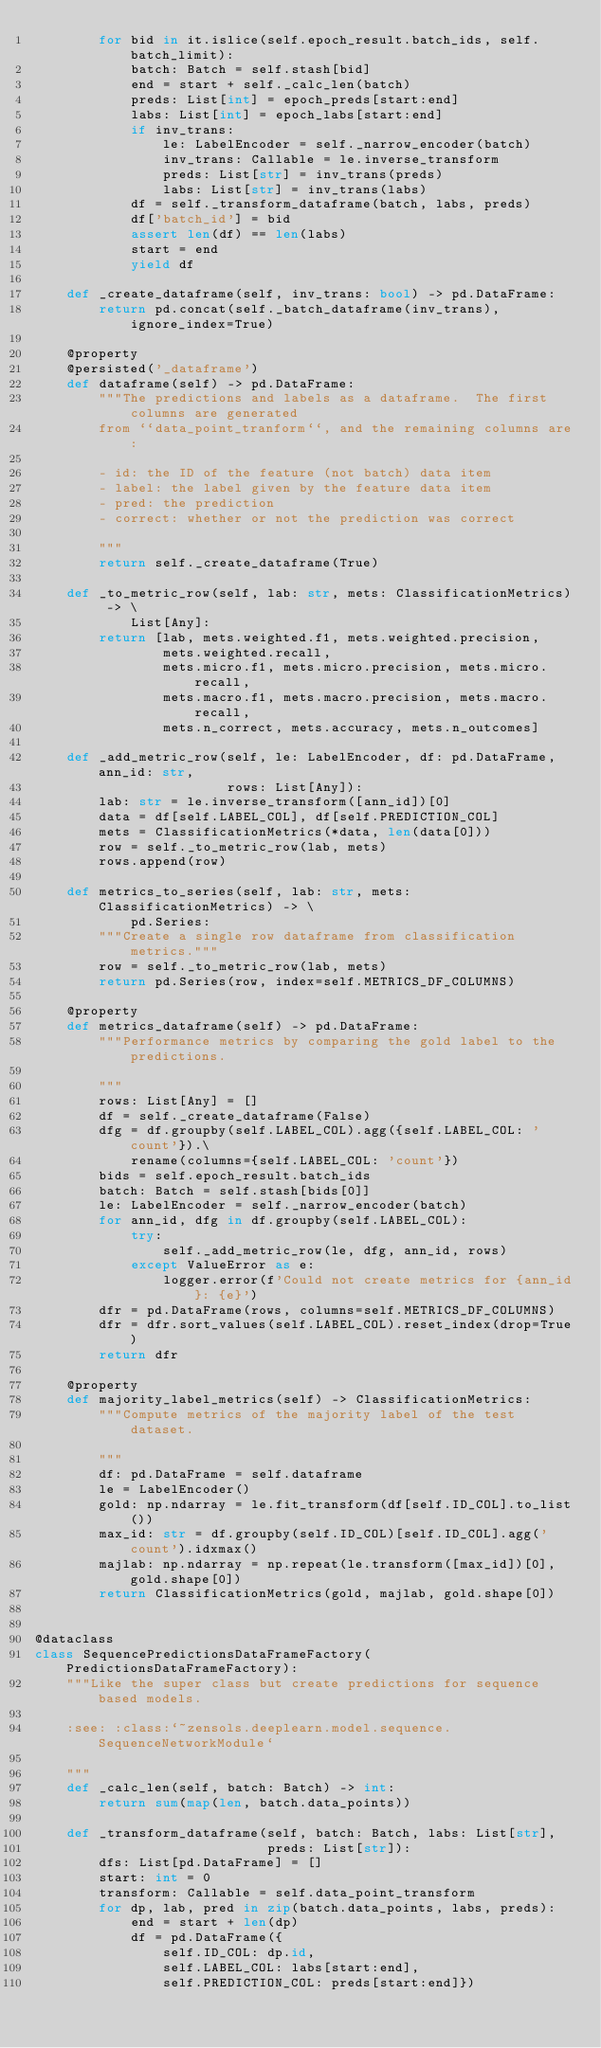<code> <loc_0><loc_0><loc_500><loc_500><_Python_>        for bid in it.islice(self.epoch_result.batch_ids, self.batch_limit):
            batch: Batch = self.stash[bid]
            end = start + self._calc_len(batch)
            preds: List[int] = epoch_preds[start:end]
            labs: List[int] = epoch_labs[start:end]
            if inv_trans:
                le: LabelEncoder = self._narrow_encoder(batch)
                inv_trans: Callable = le.inverse_transform
                preds: List[str] = inv_trans(preds)
                labs: List[str] = inv_trans(labs)
            df = self._transform_dataframe(batch, labs, preds)
            df['batch_id'] = bid
            assert len(df) == len(labs)
            start = end
            yield df

    def _create_dataframe(self, inv_trans: bool) -> pd.DataFrame:
        return pd.concat(self._batch_dataframe(inv_trans), ignore_index=True)

    @property
    @persisted('_dataframe')
    def dataframe(self) -> pd.DataFrame:
        """The predictions and labels as a dataframe.  The first columns are generated
        from ``data_point_tranform``, and the remaining columns are:

        - id: the ID of the feature (not batch) data item
        - label: the label given by the feature data item
        - pred: the prediction
        - correct: whether or not the prediction was correct

        """
        return self._create_dataframe(True)

    def _to_metric_row(self, lab: str, mets: ClassificationMetrics) -> \
            List[Any]:
        return [lab, mets.weighted.f1, mets.weighted.precision,
                mets.weighted.recall,
                mets.micro.f1, mets.micro.precision, mets.micro.recall,
                mets.macro.f1, mets.macro.precision, mets.macro.recall,
                mets.n_correct, mets.accuracy, mets.n_outcomes]

    def _add_metric_row(self, le: LabelEncoder, df: pd.DataFrame, ann_id: str,
                        rows: List[Any]):
        lab: str = le.inverse_transform([ann_id])[0]
        data = df[self.LABEL_COL], df[self.PREDICTION_COL]
        mets = ClassificationMetrics(*data, len(data[0]))
        row = self._to_metric_row(lab, mets)
        rows.append(row)

    def metrics_to_series(self, lab: str, mets: ClassificationMetrics) -> \
            pd.Series:
        """Create a single row dataframe from classification metrics."""
        row = self._to_metric_row(lab, mets)
        return pd.Series(row, index=self.METRICS_DF_COLUMNS)

    @property
    def metrics_dataframe(self) -> pd.DataFrame:
        """Performance metrics by comparing the gold label to the predictions.

        """
        rows: List[Any] = []
        df = self._create_dataframe(False)
        dfg = df.groupby(self.LABEL_COL).agg({self.LABEL_COL: 'count'}).\
            rename(columns={self.LABEL_COL: 'count'})
        bids = self.epoch_result.batch_ids
        batch: Batch = self.stash[bids[0]]
        le: LabelEncoder = self._narrow_encoder(batch)
        for ann_id, dfg in df.groupby(self.LABEL_COL):
            try:
                self._add_metric_row(le, dfg, ann_id, rows)
            except ValueError as e:
                logger.error(f'Could not create metrics for {ann_id}: {e}')
        dfr = pd.DataFrame(rows, columns=self.METRICS_DF_COLUMNS)
        dfr = dfr.sort_values(self.LABEL_COL).reset_index(drop=True)
        return dfr

    @property
    def majority_label_metrics(self) -> ClassificationMetrics:
        """Compute metrics of the majority label of the test dataset.

        """
        df: pd.DataFrame = self.dataframe
        le = LabelEncoder()
        gold: np.ndarray = le.fit_transform(df[self.ID_COL].to_list())
        max_id: str = df.groupby(self.ID_COL)[self.ID_COL].agg('count').idxmax()
        majlab: np.ndarray = np.repeat(le.transform([max_id])[0], gold.shape[0])
        return ClassificationMetrics(gold, majlab, gold.shape[0])


@dataclass
class SequencePredictionsDataFrameFactory(PredictionsDataFrameFactory):
    """Like the super class but create predictions for sequence based models.

    :see: :class:`~zensols.deeplearn.model.sequence.SequenceNetworkModule`

    """
    def _calc_len(self, batch: Batch) -> int:
        return sum(map(len, batch.data_points))

    def _transform_dataframe(self, batch: Batch, labs: List[str],
                             preds: List[str]):
        dfs: List[pd.DataFrame] = []
        start: int = 0
        transform: Callable = self.data_point_transform
        for dp, lab, pred in zip(batch.data_points, labs, preds):
            end = start + len(dp)
            df = pd.DataFrame({
                self.ID_COL: dp.id,
                self.LABEL_COL: labs[start:end],
                self.PREDICTION_COL: preds[start:end]})</code> 